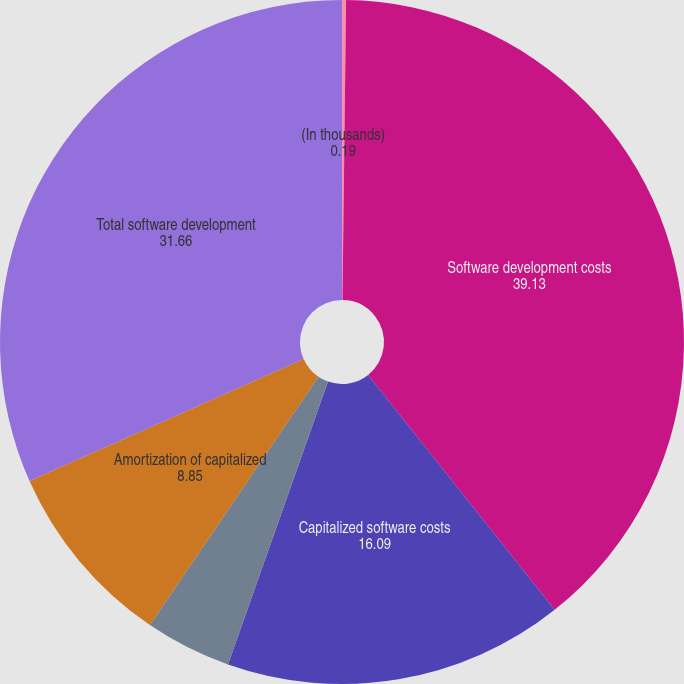<chart> <loc_0><loc_0><loc_500><loc_500><pie_chart><fcel>(In thousands)<fcel>Software development costs<fcel>Capitalized software costs<fcel>Capitalized costs related to<fcel>Amortization of capitalized<fcel>Total software development<nl><fcel>0.19%<fcel>39.13%<fcel>16.09%<fcel>4.08%<fcel>8.85%<fcel>31.66%<nl></chart> 